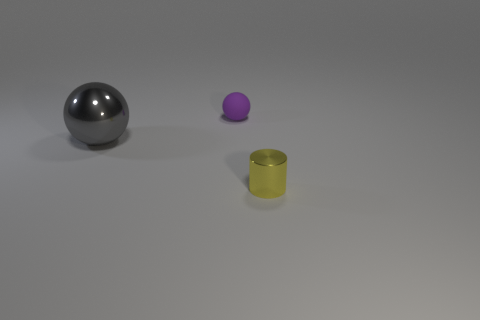There is a tiny shiny object; is it the same shape as the metallic thing on the left side of the purple rubber sphere?
Keep it short and to the point. No. What number of things are both in front of the small purple sphere and behind the metallic cylinder?
Your answer should be very brief. 1. What material is the other thing that is the same shape as the large gray object?
Your answer should be compact. Rubber. What size is the ball to the left of the sphere that is on the right side of the large metallic object?
Offer a very short reply. Large. Are any metallic balls visible?
Ensure brevity in your answer.  Yes. What material is the thing that is to the right of the gray thing and in front of the purple object?
Your response must be concise. Metal. Are there more tiny purple things in front of the small metallic object than small metallic objects behind the large metal sphere?
Your answer should be compact. No. Is there a gray metal sphere that has the same size as the metal cylinder?
Offer a very short reply. No. There is a ball in front of the object that is behind the metallic thing that is to the left of the cylinder; how big is it?
Provide a succinct answer. Large. The big sphere is what color?
Offer a terse response. Gray. 